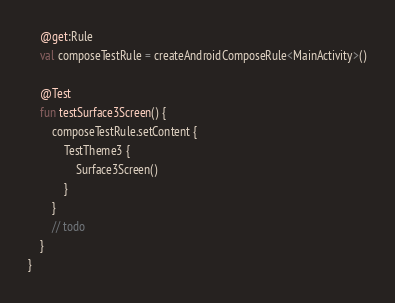<code> <loc_0><loc_0><loc_500><loc_500><_Kotlin_>    @get:Rule
    val composeTestRule = createAndroidComposeRule<MainActivity>()

    @Test
    fun testSurface3Screen() {
        composeTestRule.setContent {
            TestTheme3 {
                Surface3Screen()
            }
        }
        // todo
    }
}</code> 